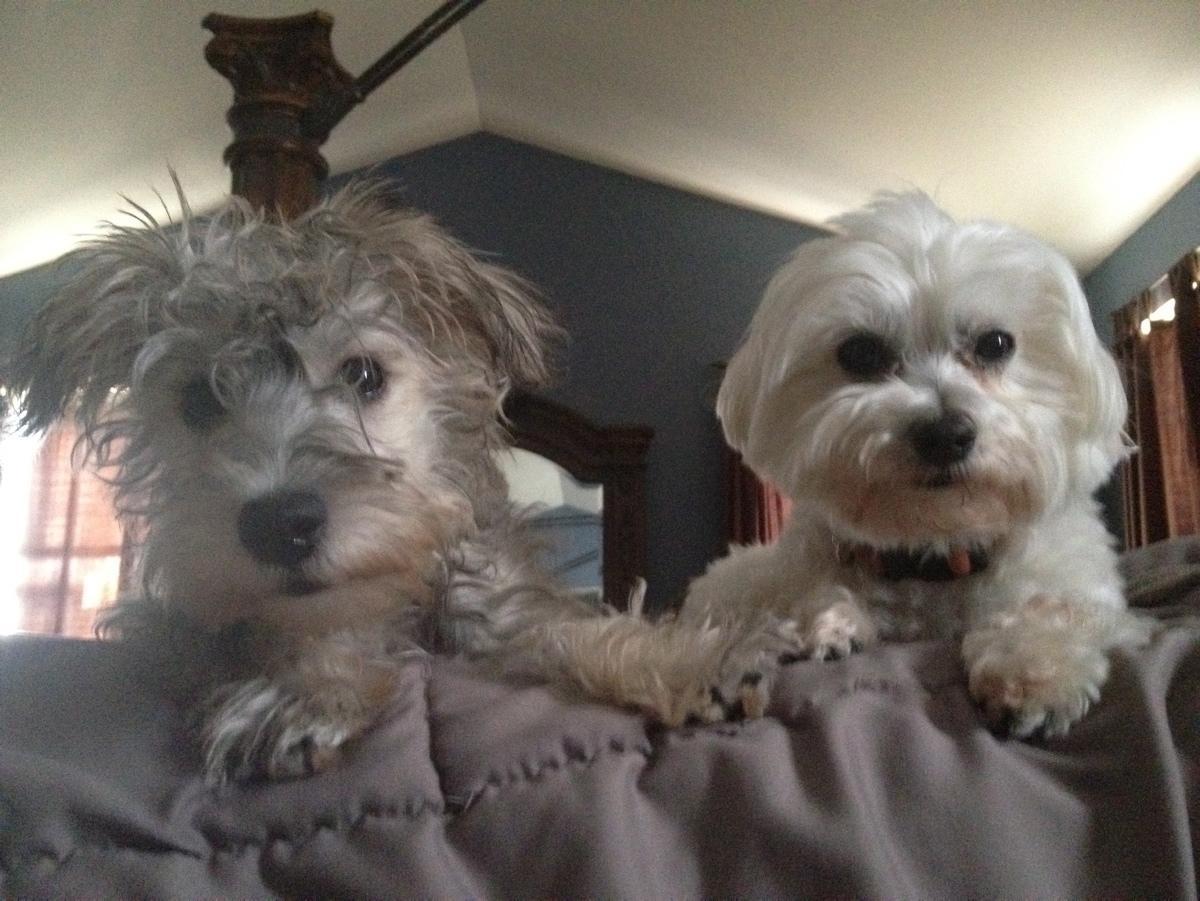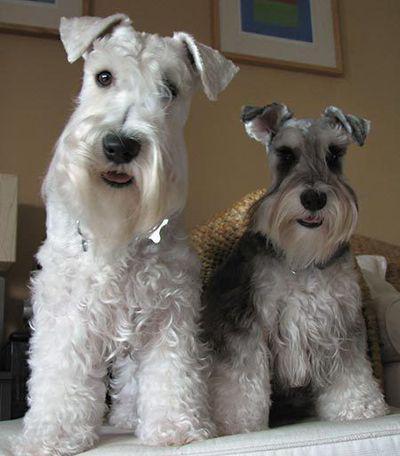The first image is the image on the left, the second image is the image on the right. Analyze the images presented: Is the assertion "a black and white dog is standing in the grass looking at the camera" valid? Answer yes or no. No. The first image is the image on the left, the second image is the image on the right. For the images shown, is this caption "At least one dog is standing on grass." true? Answer yes or no. No. 